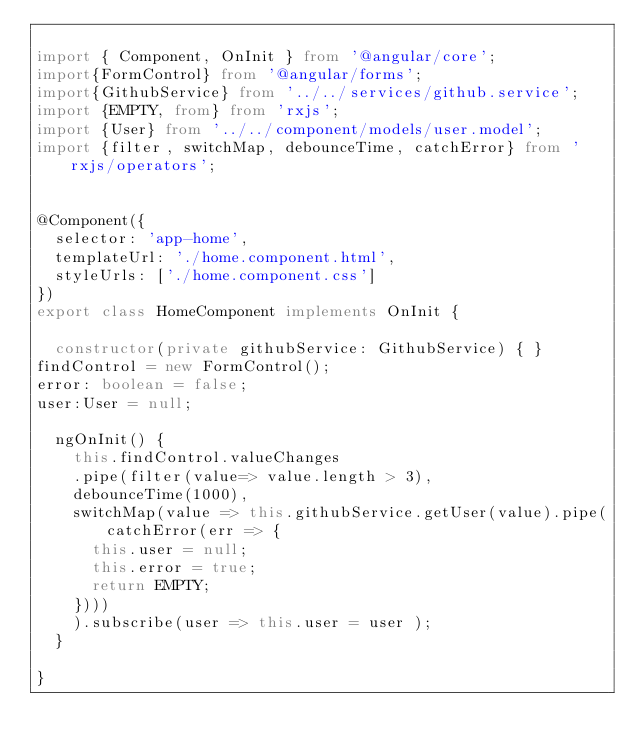Convert code to text. <code><loc_0><loc_0><loc_500><loc_500><_TypeScript_>
import { Component, OnInit } from '@angular/core';
import{FormControl} from '@angular/forms';
import{GithubService} from '../../services/github.service';
import {EMPTY, from} from 'rxjs';
import {User} from '../../component/models/user.model';
import {filter, switchMap, debounceTime, catchError} from 'rxjs/operators';


@Component({
  selector: 'app-home',
  templateUrl: './home.component.html',
  styleUrls: ['./home.component.css']
})
export class HomeComponent implements OnInit {

  constructor(private githubService: GithubService) { }
findControl = new FormControl();
error: boolean = false;
user:User = null;

  ngOnInit() {
    this.findControl.valueChanges
    .pipe(filter(value=> value.length > 3),
    debounceTime(1000),
    switchMap(value => this.githubService.getUser(value).pipe(catchError(err => {
      this.user = null;
      this.error = true;
      return EMPTY;
    })))
    ).subscribe(user => this.user = user );
  }

}
</code> 